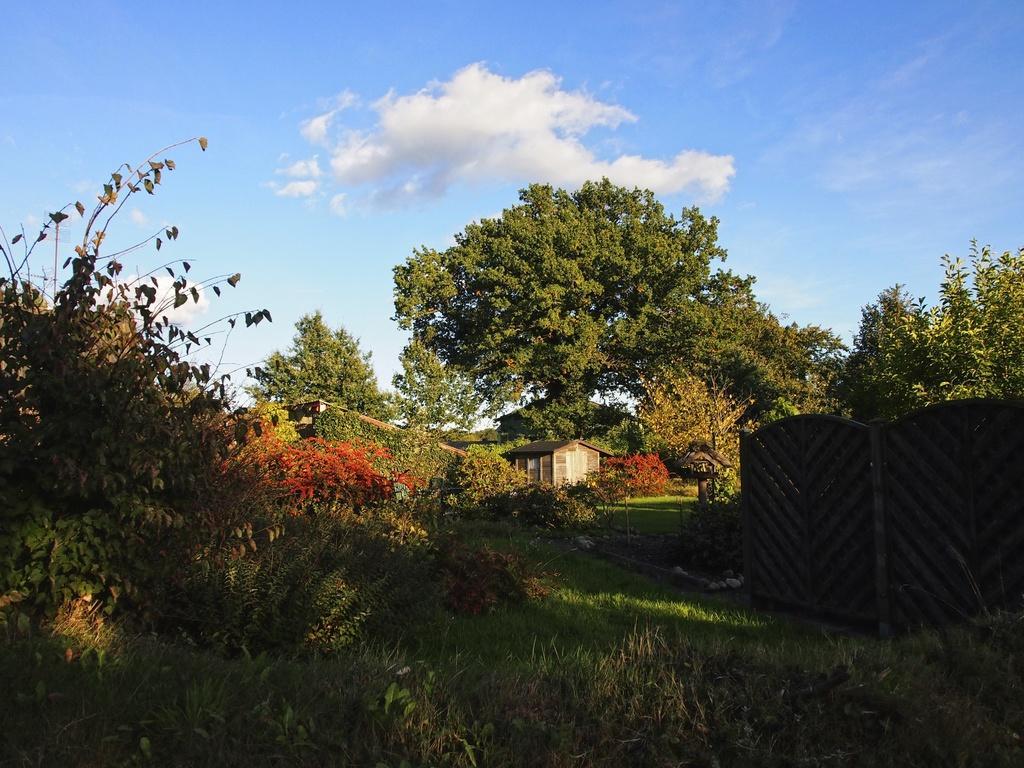Describe this image in one or two sentences. In this image I can see grass, plants, trees, houses, fence and the sky. This image is taken may be during a day. 